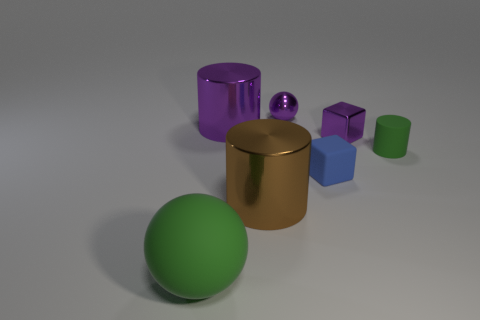Subtract all shiny cylinders. How many cylinders are left? 1 Add 1 small objects. How many objects exist? 8 Subtract all purple cylinders. How many cylinders are left? 2 Subtract all cubes. How many objects are left? 5 Add 6 small red objects. How many small red objects exist? 6 Subtract 0 brown blocks. How many objects are left? 7 Subtract all brown cubes. Subtract all red cylinders. How many cubes are left? 2 Subtract all small purple balls. Subtract all large brown objects. How many objects are left? 5 Add 2 tiny blocks. How many tiny blocks are left? 4 